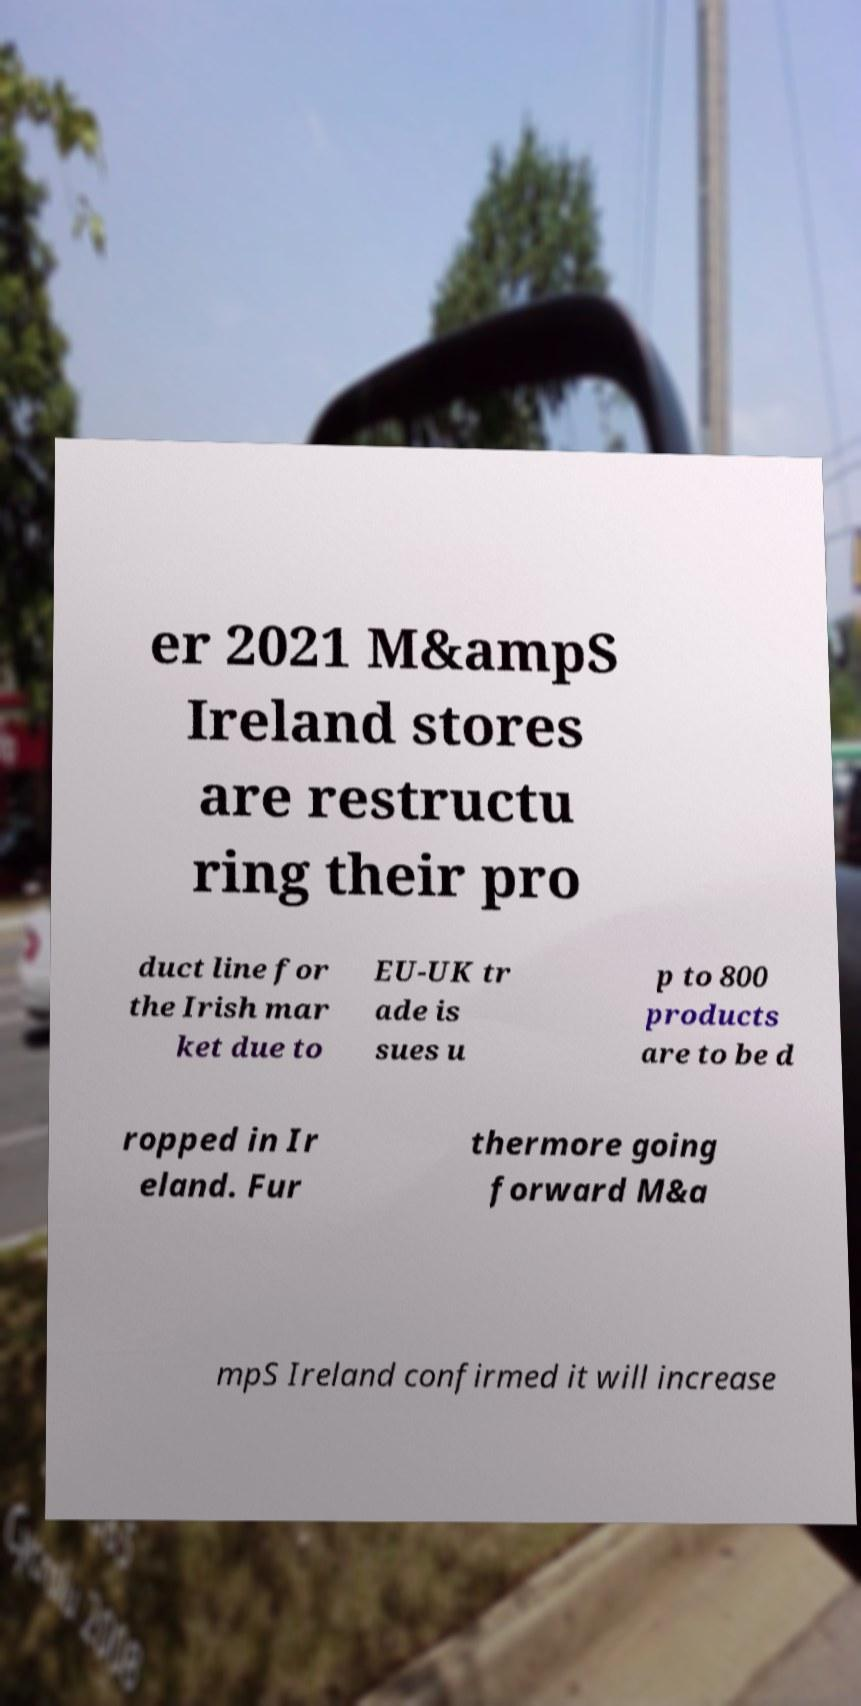What messages or text are displayed in this image? I need them in a readable, typed format. er 2021 M&ampS Ireland stores are restructu ring their pro duct line for the Irish mar ket due to EU-UK tr ade is sues u p to 800 products are to be d ropped in Ir eland. Fur thermore going forward M&a mpS Ireland confirmed it will increase 